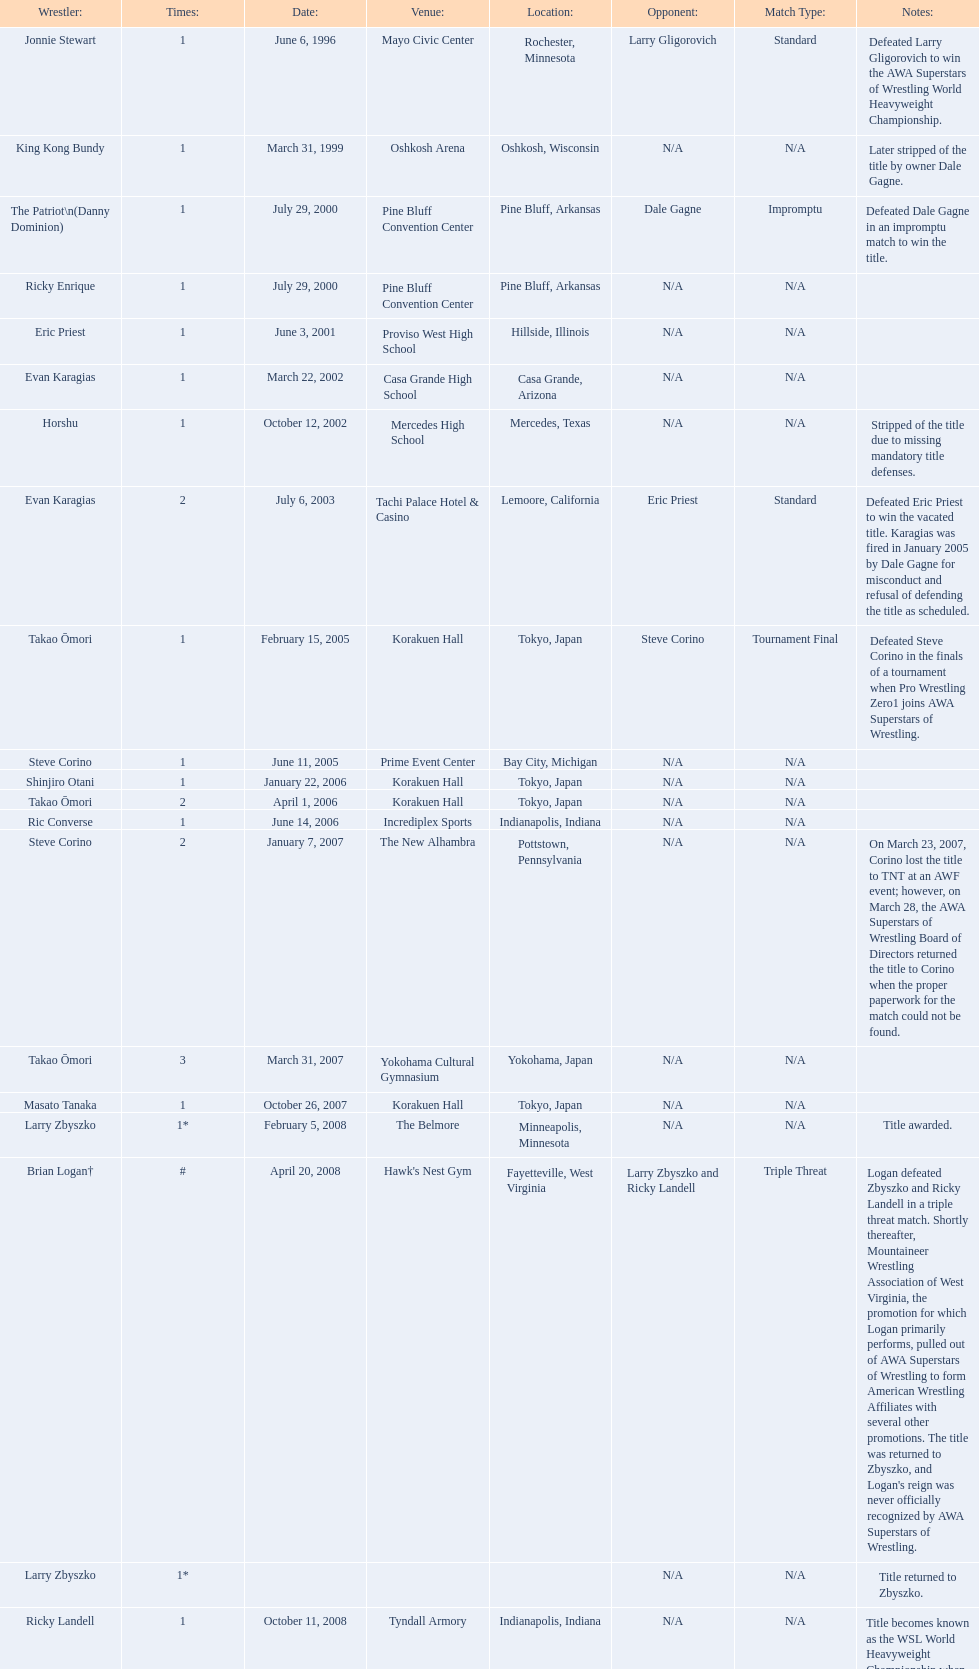What are the number of matches that happened in japan? 5. 